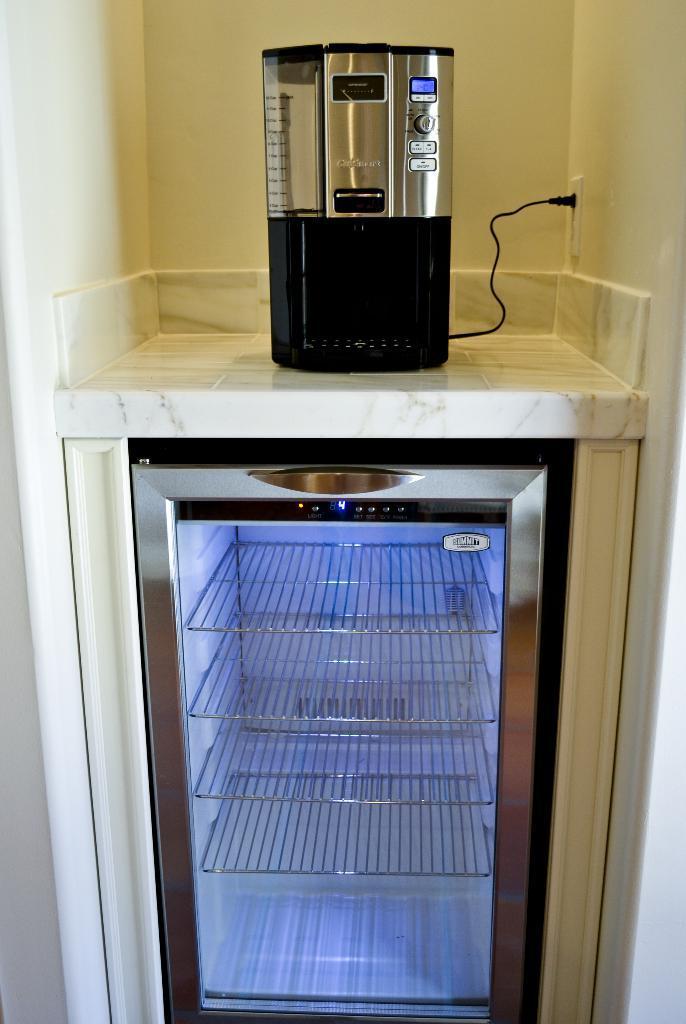Could you give a brief overview of what you see in this image? In this image I can see machines. In the background I can see a wall which has a socket. 